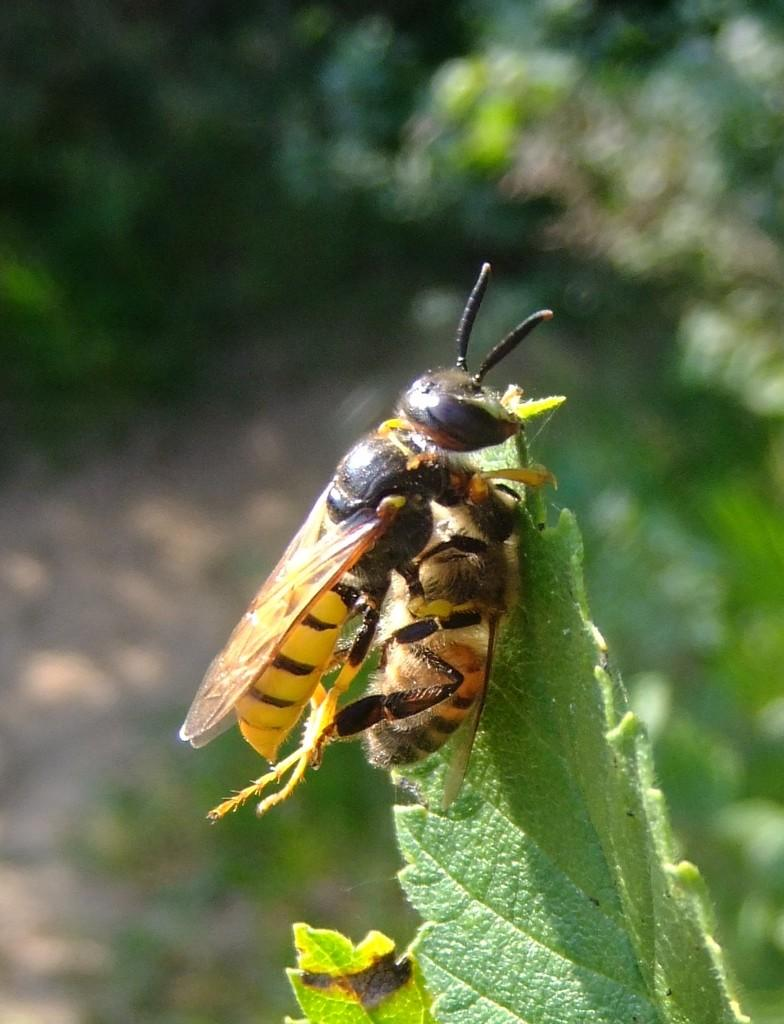How many insects are present in the image? There are two insects in the image. Where are the insects located? The insects are on a leaf. What word is being used to control the ocean in the image? There is no word or ocean present in the image; it features two insects on a leaf. 